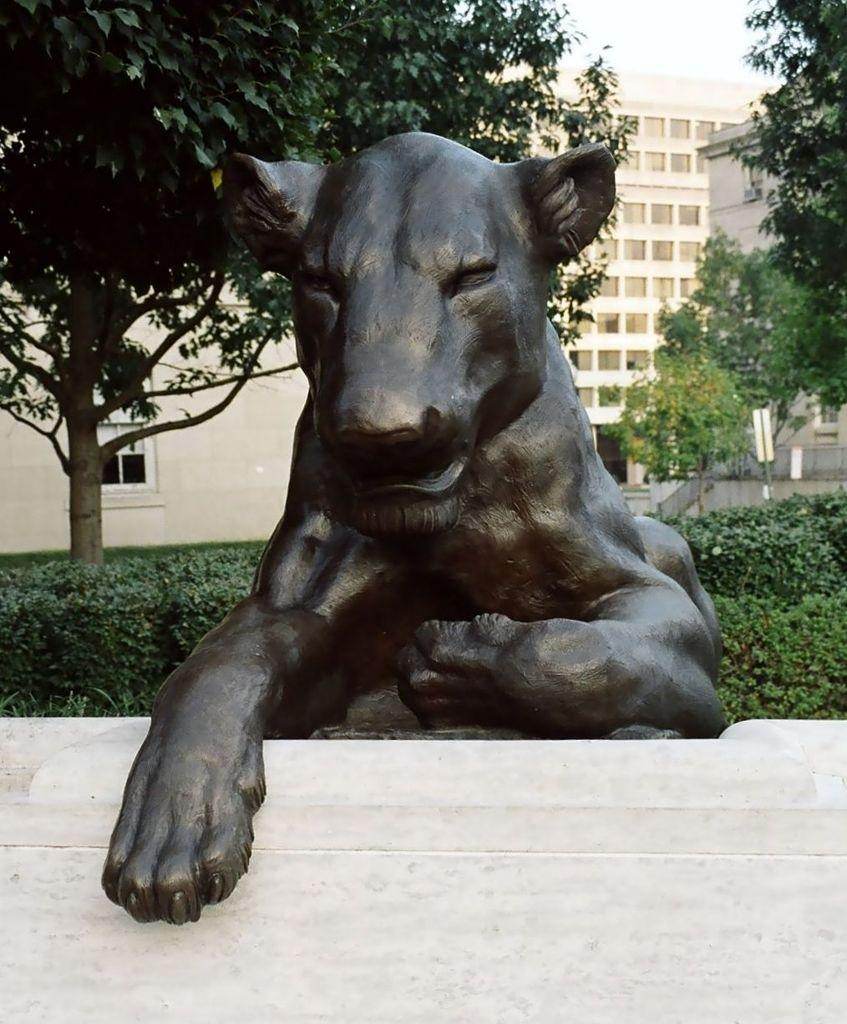What is the color of the statue in the image? The statue is black colored in the image. What type of vegetation is present in the image? There are green trees in the image. What type of structures can be seen in the image? There are buildings in the image. What is visible in the background of the image? The sky is visible in the background of the image. How does the statue express its feelings of hate towards the trees in the image? The statue is an inanimate object and does not have feelings or the ability to express emotions. 